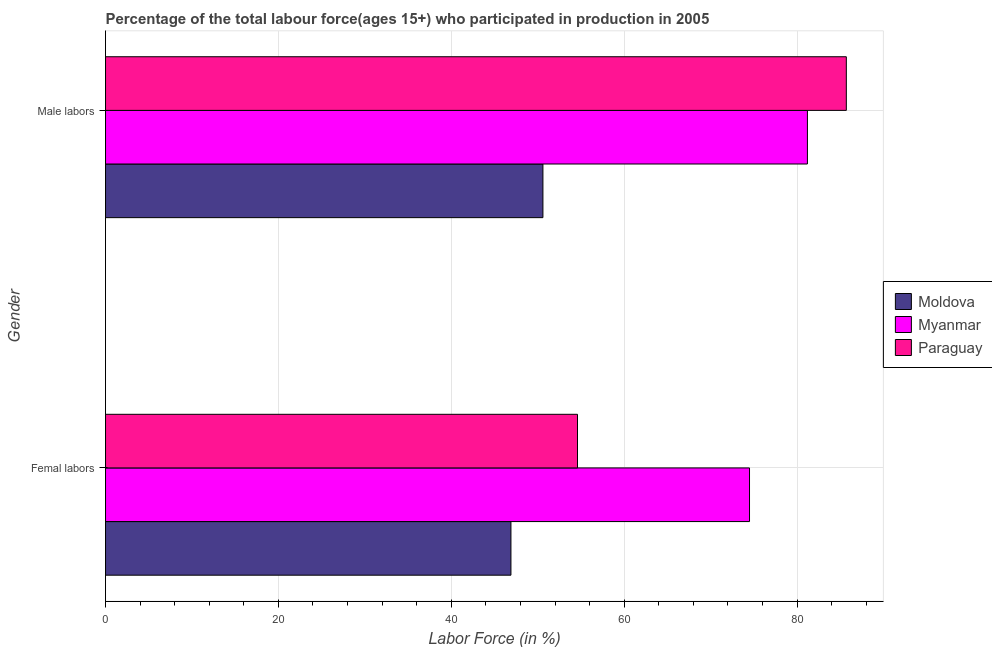How many groups of bars are there?
Make the answer very short. 2. Are the number of bars per tick equal to the number of legend labels?
Give a very brief answer. Yes. How many bars are there on the 2nd tick from the bottom?
Your answer should be very brief. 3. What is the label of the 1st group of bars from the top?
Keep it short and to the point. Male labors. What is the percentage of female labor force in Paraguay?
Give a very brief answer. 54.6. Across all countries, what is the maximum percentage of male labour force?
Provide a succinct answer. 85.7. Across all countries, what is the minimum percentage of male labour force?
Make the answer very short. 50.6. In which country was the percentage of female labor force maximum?
Your answer should be compact. Myanmar. In which country was the percentage of male labour force minimum?
Keep it short and to the point. Moldova. What is the total percentage of male labour force in the graph?
Make the answer very short. 217.5. What is the difference between the percentage of female labor force in Myanmar and that in Paraguay?
Your response must be concise. 19.9. What is the difference between the percentage of male labour force in Myanmar and the percentage of female labor force in Paraguay?
Your answer should be compact. 26.6. What is the average percentage of female labor force per country?
Provide a succinct answer. 58.67. What is the difference between the percentage of male labour force and percentage of female labor force in Myanmar?
Your answer should be compact. 6.7. What is the ratio of the percentage of male labour force in Moldova to that in Myanmar?
Your answer should be very brief. 0.62. What does the 2nd bar from the top in Male labors represents?
Offer a terse response. Myanmar. What does the 3rd bar from the bottom in Male labors represents?
Offer a terse response. Paraguay. How many bars are there?
Ensure brevity in your answer.  6. Are all the bars in the graph horizontal?
Your answer should be very brief. Yes. Does the graph contain any zero values?
Provide a short and direct response. No. Does the graph contain grids?
Your answer should be very brief. Yes. Where does the legend appear in the graph?
Provide a succinct answer. Center right. How many legend labels are there?
Keep it short and to the point. 3. What is the title of the graph?
Provide a succinct answer. Percentage of the total labour force(ages 15+) who participated in production in 2005. What is the label or title of the Y-axis?
Offer a very short reply. Gender. What is the Labor Force (in %) in Moldova in Femal labors?
Your answer should be compact. 46.9. What is the Labor Force (in %) in Myanmar in Femal labors?
Provide a succinct answer. 74.5. What is the Labor Force (in %) in Paraguay in Femal labors?
Make the answer very short. 54.6. What is the Labor Force (in %) in Moldova in Male labors?
Provide a succinct answer. 50.6. What is the Labor Force (in %) of Myanmar in Male labors?
Offer a very short reply. 81.2. What is the Labor Force (in %) in Paraguay in Male labors?
Offer a very short reply. 85.7. Across all Gender, what is the maximum Labor Force (in %) in Moldova?
Your answer should be compact. 50.6. Across all Gender, what is the maximum Labor Force (in %) in Myanmar?
Offer a very short reply. 81.2. Across all Gender, what is the maximum Labor Force (in %) in Paraguay?
Offer a terse response. 85.7. Across all Gender, what is the minimum Labor Force (in %) in Moldova?
Offer a terse response. 46.9. Across all Gender, what is the minimum Labor Force (in %) in Myanmar?
Ensure brevity in your answer.  74.5. Across all Gender, what is the minimum Labor Force (in %) of Paraguay?
Your answer should be compact. 54.6. What is the total Labor Force (in %) of Moldova in the graph?
Offer a terse response. 97.5. What is the total Labor Force (in %) of Myanmar in the graph?
Offer a very short reply. 155.7. What is the total Labor Force (in %) in Paraguay in the graph?
Offer a very short reply. 140.3. What is the difference between the Labor Force (in %) of Moldova in Femal labors and that in Male labors?
Offer a terse response. -3.7. What is the difference between the Labor Force (in %) of Myanmar in Femal labors and that in Male labors?
Your response must be concise. -6.7. What is the difference between the Labor Force (in %) in Paraguay in Femal labors and that in Male labors?
Your answer should be compact. -31.1. What is the difference between the Labor Force (in %) in Moldova in Femal labors and the Labor Force (in %) in Myanmar in Male labors?
Your answer should be compact. -34.3. What is the difference between the Labor Force (in %) in Moldova in Femal labors and the Labor Force (in %) in Paraguay in Male labors?
Provide a succinct answer. -38.8. What is the difference between the Labor Force (in %) of Myanmar in Femal labors and the Labor Force (in %) of Paraguay in Male labors?
Your answer should be very brief. -11.2. What is the average Labor Force (in %) in Moldova per Gender?
Provide a short and direct response. 48.75. What is the average Labor Force (in %) of Myanmar per Gender?
Your response must be concise. 77.85. What is the average Labor Force (in %) in Paraguay per Gender?
Ensure brevity in your answer.  70.15. What is the difference between the Labor Force (in %) in Moldova and Labor Force (in %) in Myanmar in Femal labors?
Your answer should be compact. -27.6. What is the difference between the Labor Force (in %) of Myanmar and Labor Force (in %) of Paraguay in Femal labors?
Give a very brief answer. 19.9. What is the difference between the Labor Force (in %) in Moldova and Labor Force (in %) in Myanmar in Male labors?
Offer a terse response. -30.6. What is the difference between the Labor Force (in %) in Moldova and Labor Force (in %) in Paraguay in Male labors?
Your response must be concise. -35.1. What is the ratio of the Labor Force (in %) of Moldova in Femal labors to that in Male labors?
Offer a very short reply. 0.93. What is the ratio of the Labor Force (in %) in Myanmar in Femal labors to that in Male labors?
Your response must be concise. 0.92. What is the ratio of the Labor Force (in %) in Paraguay in Femal labors to that in Male labors?
Your answer should be very brief. 0.64. What is the difference between the highest and the second highest Labor Force (in %) of Paraguay?
Give a very brief answer. 31.1. What is the difference between the highest and the lowest Labor Force (in %) in Myanmar?
Provide a succinct answer. 6.7. What is the difference between the highest and the lowest Labor Force (in %) of Paraguay?
Provide a short and direct response. 31.1. 